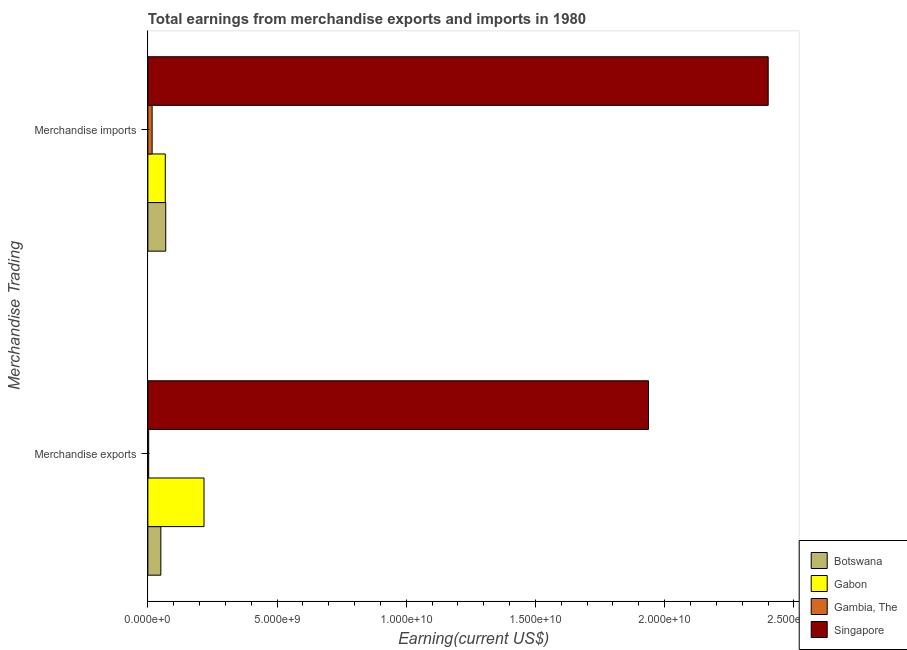How many different coloured bars are there?
Keep it short and to the point. 4. Are the number of bars per tick equal to the number of legend labels?
Your response must be concise. Yes. How many bars are there on the 1st tick from the top?
Offer a very short reply. 4. What is the label of the 2nd group of bars from the top?
Keep it short and to the point. Merchandise exports. What is the earnings from merchandise imports in Singapore?
Provide a succinct answer. 2.40e+1. Across all countries, what is the maximum earnings from merchandise exports?
Your answer should be compact. 1.94e+1. Across all countries, what is the minimum earnings from merchandise imports?
Make the answer very short. 1.65e+08. In which country was the earnings from merchandise imports maximum?
Your answer should be compact. Singapore. In which country was the earnings from merchandise exports minimum?
Give a very brief answer. Gambia, The. What is the total earnings from merchandise imports in the graph?
Your response must be concise. 2.55e+1. What is the difference between the earnings from merchandise imports in Botswana and that in Gambia, The?
Your response must be concise. 5.27e+08. What is the difference between the earnings from merchandise exports in Singapore and the earnings from merchandise imports in Botswana?
Offer a very short reply. 1.87e+1. What is the average earnings from merchandise exports per country?
Your answer should be compact. 5.52e+09. What is the difference between the earnings from merchandise imports and earnings from merchandise exports in Gambia, The?
Ensure brevity in your answer.  1.34e+08. In how many countries, is the earnings from merchandise exports greater than 10000000000 US$?
Offer a terse response. 1. What is the ratio of the earnings from merchandise imports in Gambia, The to that in Botswana?
Ensure brevity in your answer.  0.24. What does the 1st bar from the top in Merchandise imports represents?
Make the answer very short. Singapore. What does the 3rd bar from the bottom in Merchandise exports represents?
Keep it short and to the point. Gambia, The. How many bars are there?
Give a very brief answer. 8. How many countries are there in the graph?
Give a very brief answer. 4. Does the graph contain any zero values?
Provide a succinct answer. No. Does the graph contain grids?
Make the answer very short. No. Where does the legend appear in the graph?
Give a very brief answer. Bottom right. What is the title of the graph?
Give a very brief answer. Total earnings from merchandise exports and imports in 1980. Does "Aruba" appear as one of the legend labels in the graph?
Your response must be concise. No. What is the label or title of the X-axis?
Your answer should be very brief. Earning(current US$). What is the label or title of the Y-axis?
Give a very brief answer. Merchandise Trading. What is the Earning(current US$) in Botswana in Merchandise exports?
Ensure brevity in your answer.  5.02e+08. What is the Earning(current US$) in Gabon in Merchandise exports?
Make the answer very short. 2.17e+09. What is the Earning(current US$) of Gambia, The in Merchandise exports?
Keep it short and to the point. 3.10e+07. What is the Earning(current US$) of Singapore in Merchandise exports?
Your response must be concise. 1.94e+1. What is the Earning(current US$) in Botswana in Merchandise imports?
Your response must be concise. 6.92e+08. What is the Earning(current US$) of Gabon in Merchandise imports?
Offer a terse response. 6.74e+08. What is the Earning(current US$) of Gambia, The in Merchandise imports?
Ensure brevity in your answer.  1.65e+08. What is the Earning(current US$) in Singapore in Merchandise imports?
Give a very brief answer. 2.40e+1. Across all Merchandise Trading, what is the maximum Earning(current US$) in Botswana?
Ensure brevity in your answer.  6.92e+08. Across all Merchandise Trading, what is the maximum Earning(current US$) in Gabon?
Offer a terse response. 2.17e+09. Across all Merchandise Trading, what is the maximum Earning(current US$) in Gambia, The?
Offer a very short reply. 1.65e+08. Across all Merchandise Trading, what is the maximum Earning(current US$) of Singapore?
Make the answer very short. 2.40e+1. Across all Merchandise Trading, what is the minimum Earning(current US$) in Botswana?
Your answer should be compact. 5.02e+08. Across all Merchandise Trading, what is the minimum Earning(current US$) in Gabon?
Provide a succinct answer. 6.74e+08. Across all Merchandise Trading, what is the minimum Earning(current US$) in Gambia, The?
Make the answer very short. 3.10e+07. Across all Merchandise Trading, what is the minimum Earning(current US$) in Singapore?
Your answer should be compact. 1.94e+1. What is the total Earning(current US$) in Botswana in the graph?
Offer a terse response. 1.19e+09. What is the total Earning(current US$) of Gabon in the graph?
Provide a short and direct response. 2.85e+09. What is the total Earning(current US$) in Gambia, The in the graph?
Your answer should be compact. 1.96e+08. What is the total Earning(current US$) in Singapore in the graph?
Provide a short and direct response. 4.34e+1. What is the difference between the Earning(current US$) of Botswana in Merchandise exports and that in Merchandise imports?
Provide a succinct answer. -1.90e+08. What is the difference between the Earning(current US$) of Gabon in Merchandise exports and that in Merchandise imports?
Keep it short and to the point. 1.50e+09. What is the difference between the Earning(current US$) in Gambia, The in Merchandise exports and that in Merchandise imports?
Give a very brief answer. -1.34e+08. What is the difference between the Earning(current US$) in Singapore in Merchandise exports and that in Merchandise imports?
Offer a very short reply. -4.63e+09. What is the difference between the Earning(current US$) in Botswana in Merchandise exports and the Earning(current US$) in Gabon in Merchandise imports?
Offer a very short reply. -1.72e+08. What is the difference between the Earning(current US$) in Botswana in Merchandise exports and the Earning(current US$) in Gambia, The in Merchandise imports?
Offer a very short reply. 3.37e+08. What is the difference between the Earning(current US$) in Botswana in Merchandise exports and the Earning(current US$) in Singapore in Merchandise imports?
Provide a short and direct response. -2.35e+1. What is the difference between the Earning(current US$) in Gabon in Merchandise exports and the Earning(current US$) in Gambia, The in Merchandise imports?
Offer a terse response. 2.01e+09. What is the difference between the Earning(current US$) of Gabon in Merchandise exports and the Earning(current US$) of Singapore in Merchandise imports?
Provide a succinct answer. -2.18e+1. What is the difference between the Earning(current US$) in Gambia, The in Merchandise exports and the Earning(current US$) in Singapore in Merchandise imports?
Offer a terse response. -2.40e+1. What is the average Earning(current US$) of Botswana per Merchandise Trading?
Make the answer very short. 5.97e+08. What is the average Earning(current US$) in Gabon per Merchandise Trading?
Offer a terse response. 1.42e+09. What is the average Earning(current US$) in Gambia, The per Merchandise Trading?
Offer a very short reply. 9.80e+07. What is the average Earning(current US$) of Singapore per Merchandise Trading?
Give a very brief answer. 2.17e+1. What is the difference between the Earning(current US$) in Botswana and Earning(current US$) in Gabon in Merchandise exports?
Your answer should be very brief. -1.67e+09. What is the difference between the Earning(current US$) in Botswana and Earning(current US$) in Gambia, The in Merchandise exports?
Offer a terse response. 4.71e+08. What is the difference between the Earning(current US$) of Botswana and Earning(current US$) of Singapore in Merchandise exports?
Offer a very short reply. -1.89e+1. What is the difference between the Earning(current US$) of Gabon and Earning(current US$) of Gambia, The in Merchandise exports?
Your response must be concise. 2.14e+09. What is the difference between the Earning(current US$) in Gabon and Earning(current US$) in Singapore in Merchandise exports?
Your answer should be very brief. -1.72e+1. What is the difference between the Earning(current US$) in Gambia, The and Earning(current US$) in Singapore in Merchandise exports?
Give a very brief answer. -1.93e+1. What is the difference between the Earning(current US$) of Botswana and Earning(current US$) of Gabon in Merchandise imports?
Your answer should be compact. 1.80e+07. What is the difference between the Earning(current US$) of Botswana and Earning(current US$) of Gambia, The in Merchandise imports?
Your answer should be very brief. 5.27e+08. What is the difference between the Earning(current US$) in Botswana and Earning(current US$) in Singapore in Merchandise imports?
Give a very brief answer. -2.33e+1. What is the difference between the Earning(current US$) of Gabon and Earning(current US$) of Gambia, The in Merchandise imports?
Keep it short and to the point. 5.09e+08. What is the difference between the Earning(current US$) in Gabon and Earning(current US$) in Singapore in Merchandise imports?
Offer a terse response. -2.33e+1. What is the difference between the Earning(current US$) of Gambia, The and Earning(current US$) of Singapore in Merchandise imports?
Your answer should be compact. -2.38e+1. What is the ratio of the Earning(current US$) in Botswana in Merchandise exports to that in Merchandise imports?
Your response must be concise. 0.73. What is the ratio of the Earning(current US$) in Gabon in Merchandise exports to that in Merchandise imports?
Your response must be concise. 3.22. What is the ratio of the Earning(current US$) in Gambia, The in Merchandise exports to that in Merchandise imports?
Your response must be concise. 0.19. What is the ratio of the Earning(current US$) of Singapore in Merchandise exports to that in Merchandise imports?
Your answer should be very brief. 0.81. What is the difference between the highest and the second highest Earning(current US$) in Botswana?
Offer a terse response. 1.90e+08. What is the difference between the highest and the second highest Earning(current US$) in Gabon?
Ensure brevity in your answer.  1.50e+09. What is the difference between the highest and the second highest Earning(current US$) of Gambia, The?
Your answer should be very brief. 1.34e+08. What is the difference between the highest and the second highest Earning(current US$) in Singapore?
Make the answer very short. 4.63e+09. What is the difference between the highest and the lowest Earning(current US$) of Botswana?
Provide a short and direct response. 1.90e+08. What is the difference between the highest and the lowest Earning(current US$) of Gabon?
Offer a terse response. 1.50e+09. What is the difference between the highest and the lowest Earning(current US$) in Gambia, The?
Ensure brevity in your answer.  1.34e+08. What is the difference between the highest and the lowest Earning(current US$) in Singapore?
Your answer should be very brief. 4.63e+09. 